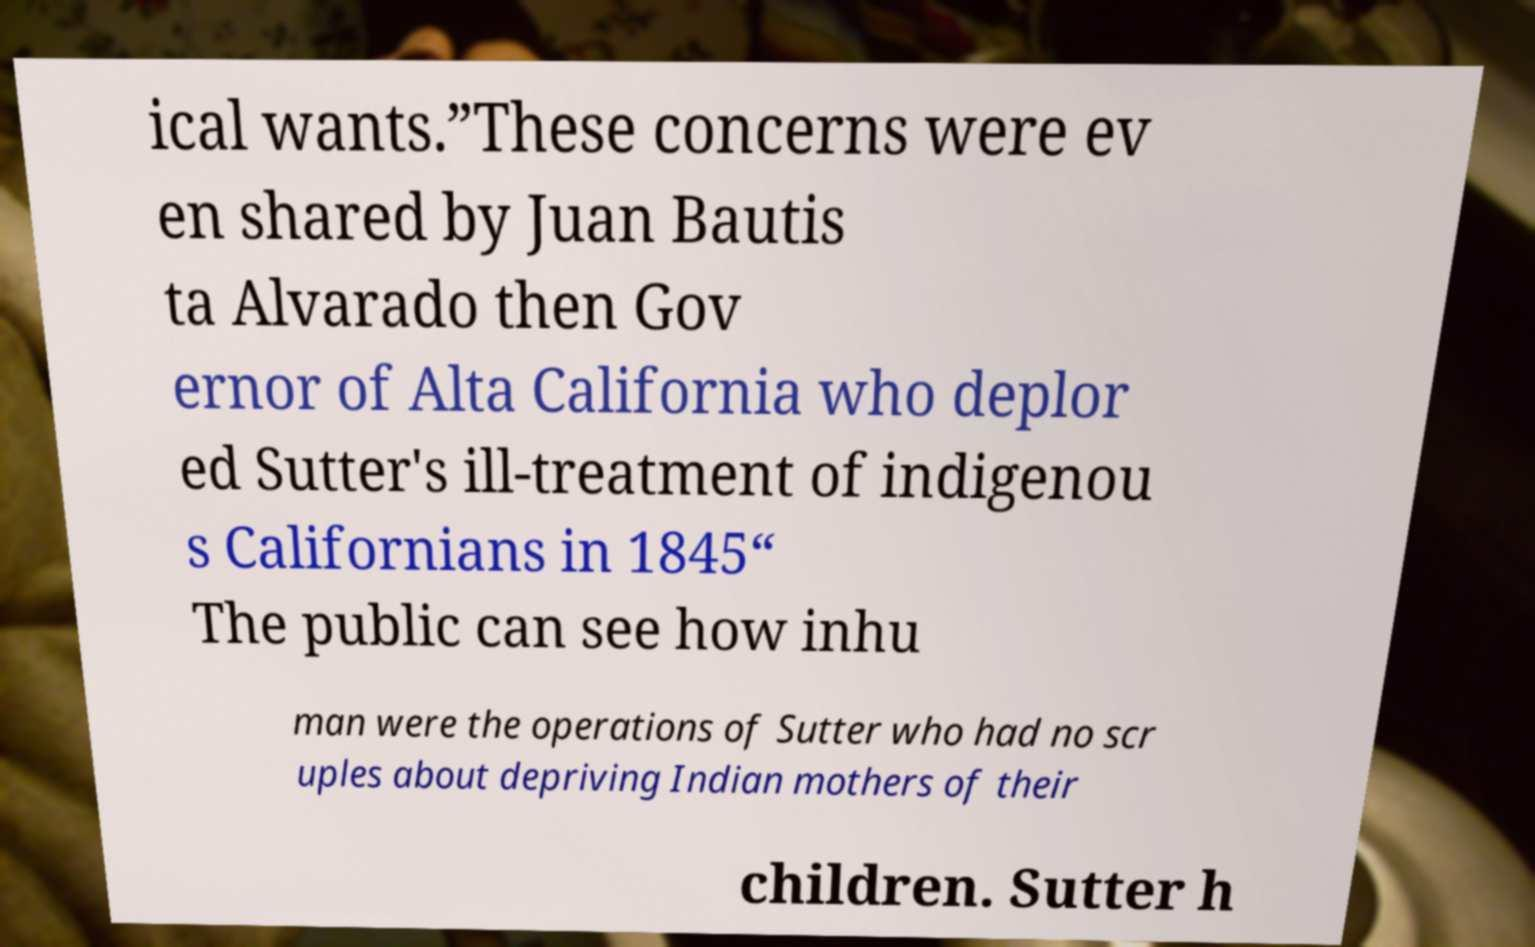Please read and relay the text visible in this image. What does it say? ical wants.”These concerns were ev en shared by Juan Bautis ta Alvarado then Gov ernor of Alta California who deplor ed Sutter's ill-treatment of indigenou s Californians in 1845“ The public can see how inhu man were the operations of Sutter who had no scr uples about depriving Indian mothers of their children. Sutter h 